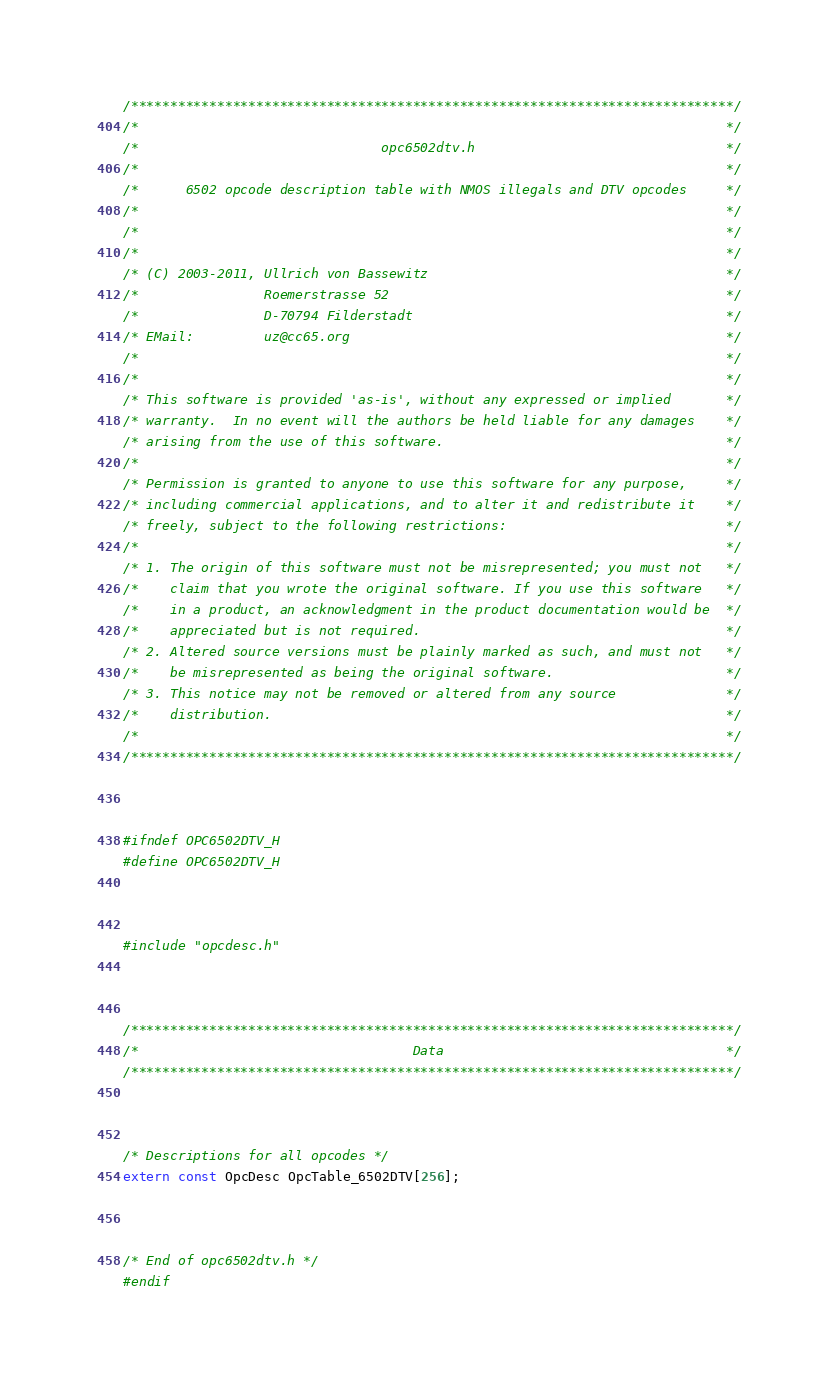Convert code to text. <code><loc_0><loc_0><loc_500><loc_500><_C_>/*****************************************************************************/
/*                                                                           */
/*                               opc6502dtv.h                                */
/*                                                                           */
/*      6502 opcode description table with NMOS illegals and DTV opcodes     */
/*                                                                           */
/*                                                                           */
/*                                                                           */
/* (C) 2003-2011, Ullrich von Bassewitz                                      */
/*                Roemerstrasse 52                                           */
/*                D-70794 Filderstadt                                        */
/* EMail:         uz@cc65.org                                                */
/*                                                                           */
/*                                                                           */
/* This software is provided 'as-is', without any expressed or implied       */
/* warranty.  In no event will the authors be held liable for any damages    */
/* arising from the use of this software.                                    */
/*                                                                           */
/* Permission is granted to anyone to use this software for any purpose,     */
/* including commercial applications, and to alter it and redistribute it    */
/* freely, subject to the following restrictions:                            */
/*                                                                           */
/* 1. The origin of this software must not be misrepresented; you must not   */
/*    claim that you wrote the original software. If you use this software   */
/*    in a product, an acknowledgment in the product documentation would be  */
/*    appreciated but is not required.                                       */
/* 2. Altered source versions must be plainly marked as such, and must not   */
/*    be misrepresented as being the original software.                      */
/* 3. This notice may not be removed or altered from any source              */
/*    distribution.                                                          */
/*                                                                           */
/*****************************************************************************/



#ifndef OPC6502DTV_H
#define OPC6502DTV_H



#include "opcdesc.h"



/*****************************************************************************/
/*                                   Data                                    */
/*****************************************************************************/



/* Descriptions for all opcodes */
extern const OpcDesc OpcTable_6502DTV[256];



/* End of opc6502dtv.h */
#endif




</code> 